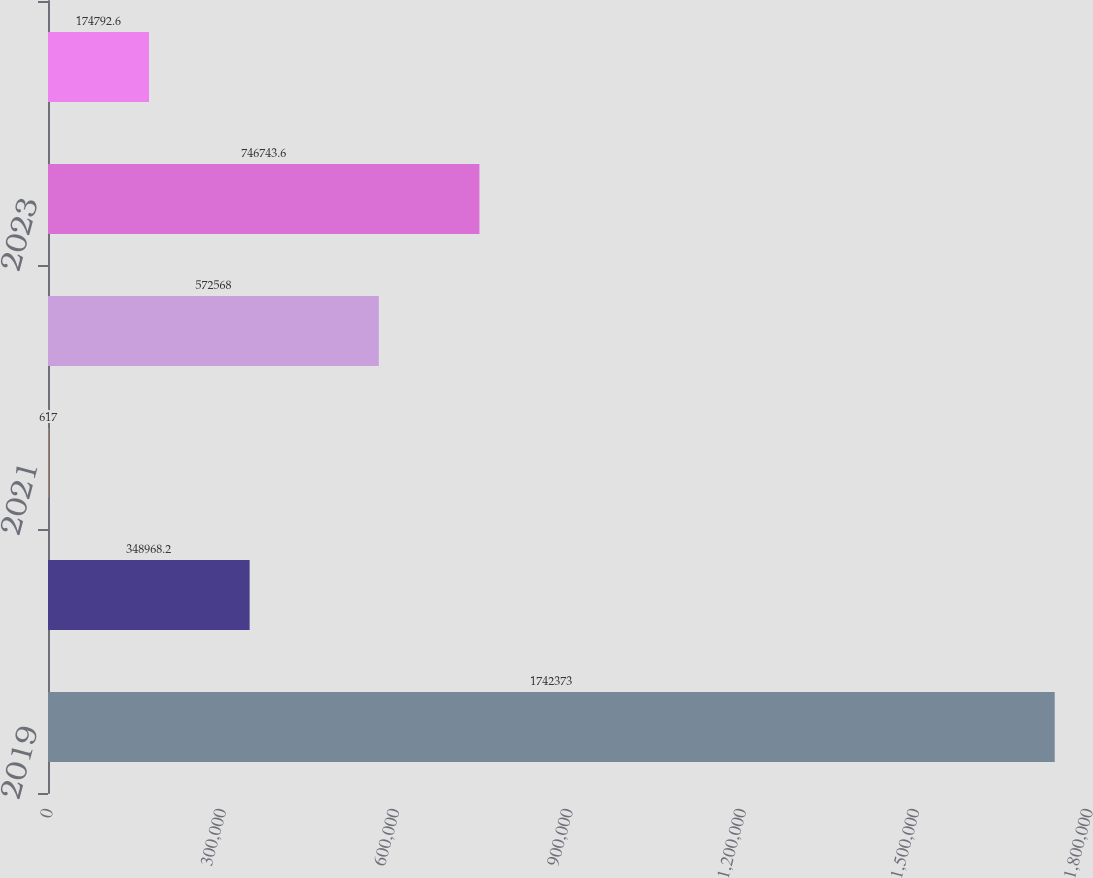Convert chart. <chart><loc_0><loc_0><loc_500><loc_500><bar_chart><fcel>2019<fcel>2020<fcel>2021<fcel>2022<fcel>2023<fcel>Thereafter<nl><fcel>1.74237e+06<fcel>348968<fcel>617<fcel>572568<fcel>746744<fcel>174793<nl></chart> 